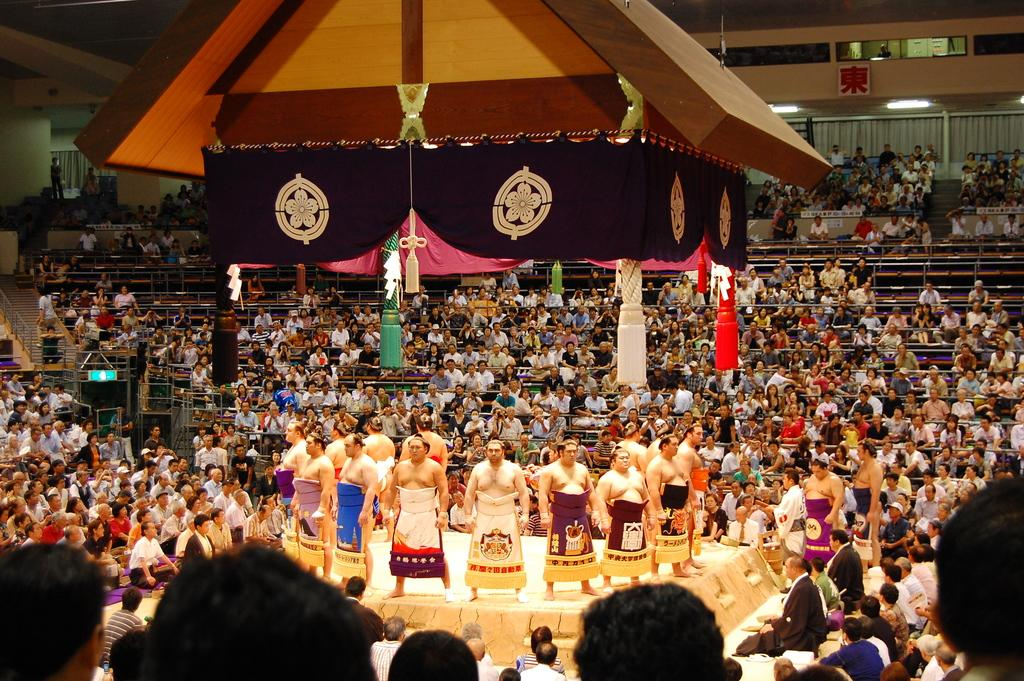What are the persons in the image doing? Some persons are standing on the floor, while others are sitting on the stairs. What can be seen in the image that might provide support for the persons? Railings are present in the image. What type of decorations can be seen in the image? Decors are visible in the image. What type of lighting is present in the image? Electric lights are present in the image. What type of window treatment is associated with the doors in the image? Curtains are associated with the doors in the image. What type of breakfast is being served in the image? There is no breakfast visible in the image. What type of behavior is being exhibited by the persons in the image? The image does not provide information about the behavior of the persons; it only shows their positions (standing or sitting). 